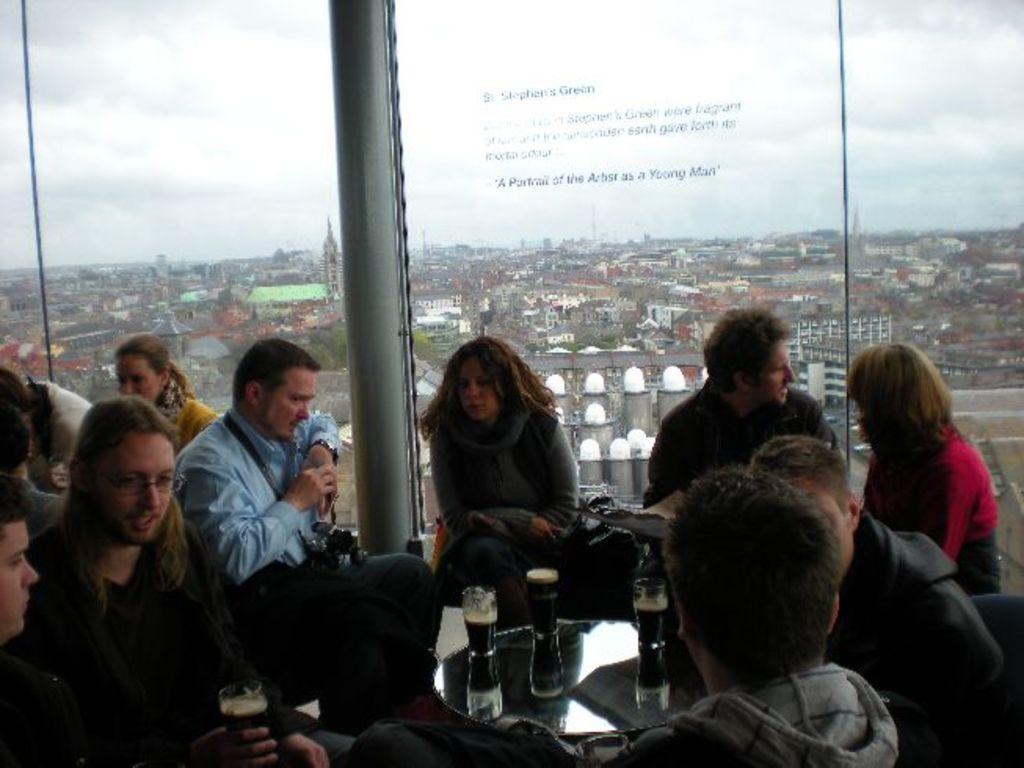Describe this image in one or two sentences. In this picture we can see some group of people are sitting in one place, in front there is a table on which some glasses are placed, we can see glass windows. 